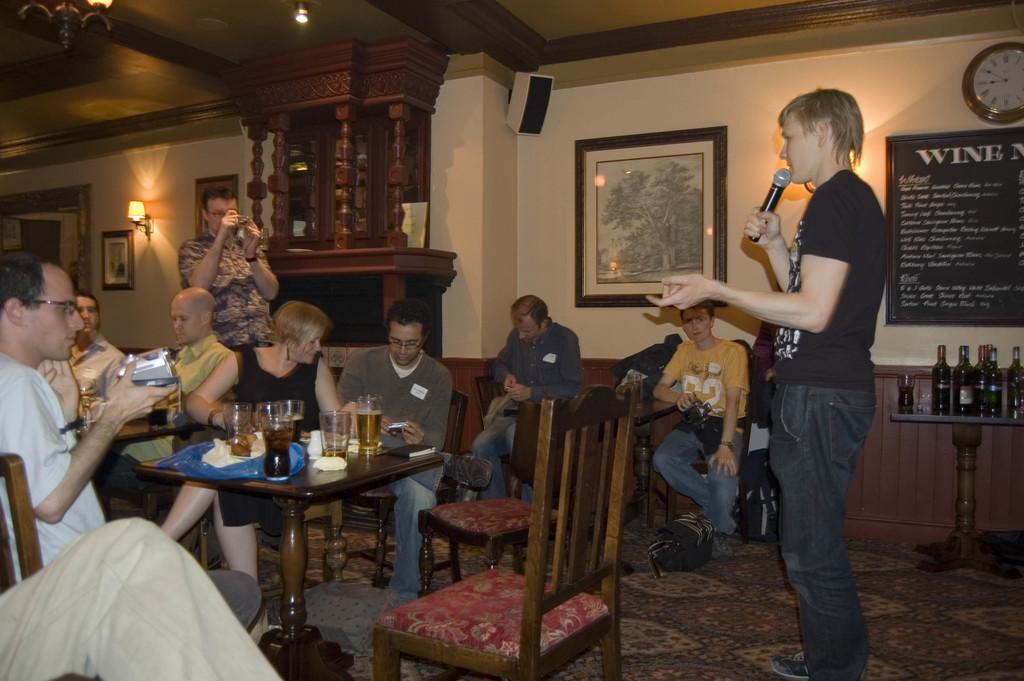What type of structure can be seen in the image? There is a wall in the image. What time-telling device is present in the image? There is a clock in the image. What is used for displaying photos in the image? There is a photo frame in the image. What are the people in the image doing? There are people sitting on chairs in the image. What piece of furniture is present in the image? There is a table in the image. What items can be seen on the table in the image? There is a glass and a bottle on the table in the image. What type of game is being played on the table in the image? There is no game being played on the table in the image; it only contains a glass and a bottle. How many orders can be seen on the table in the image? There is no reference to orders in the image; it only contains a glass and a bottle. 